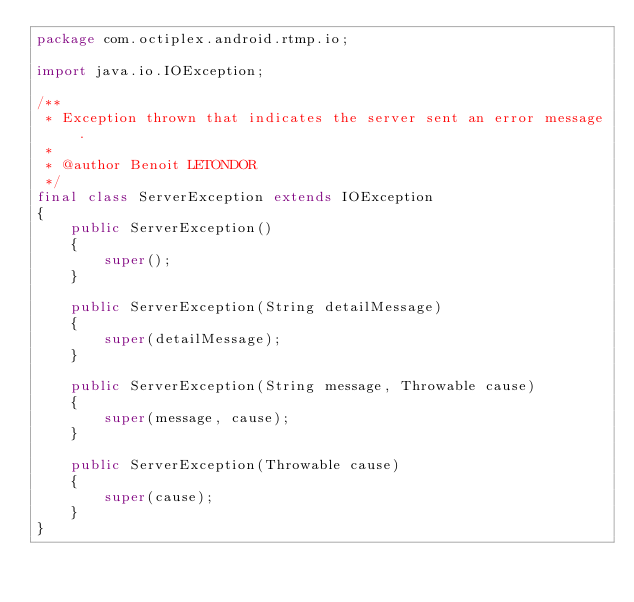Convert code to text. <code><loc_0><loc_0><loc_500><loc_500><_Java_>package com.octiplex.android.rtmp.io;

import java.io.IOException;

/**
 * Exception thrown that indicates the server sent an error message.
 *
 * @author Benoit LETONDOR
 */
final class ServerException extends IOException
{
    public ServerException()
    {
        super();
    }

    public ServerException(String detailMessage)
    {
        super(detailMessage);
    }

    public ServerException(String message, Throwable cause)
    {
        super(message, cause);
    }

    public ServerException(Throwable cause)
    {
        super(cause);
    }
}
</code> 